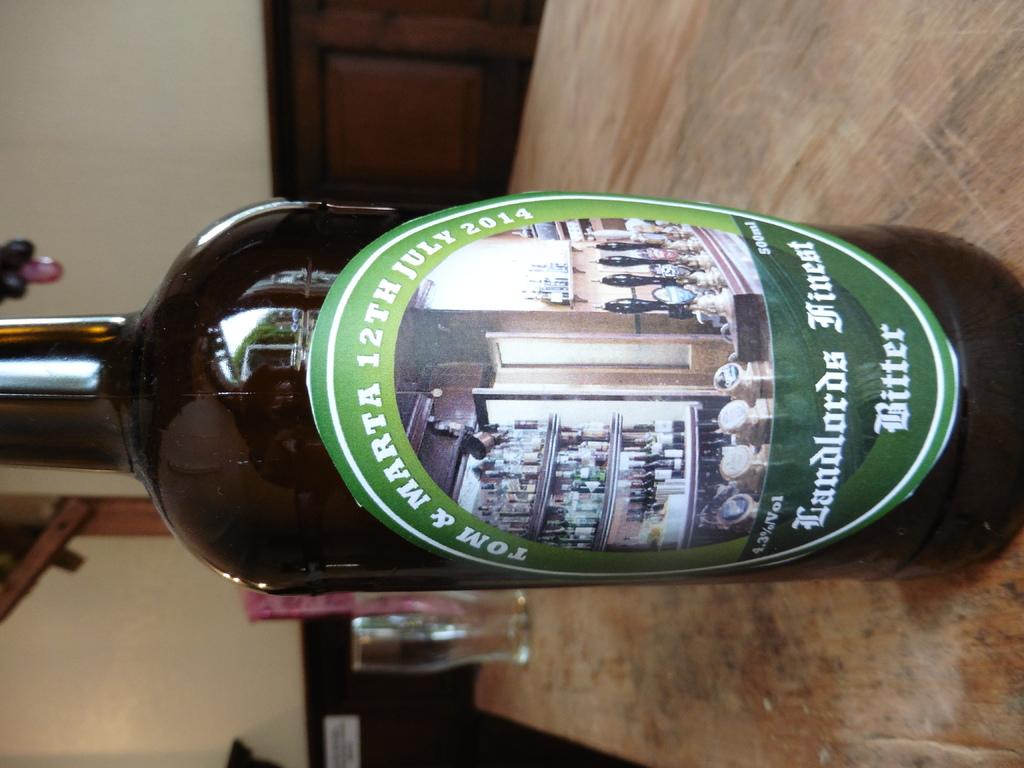<image>
Present a compact description of the photo's key features. A bottle of Tom & Marta 12th July 2014 Landlords Finest Bitter. 